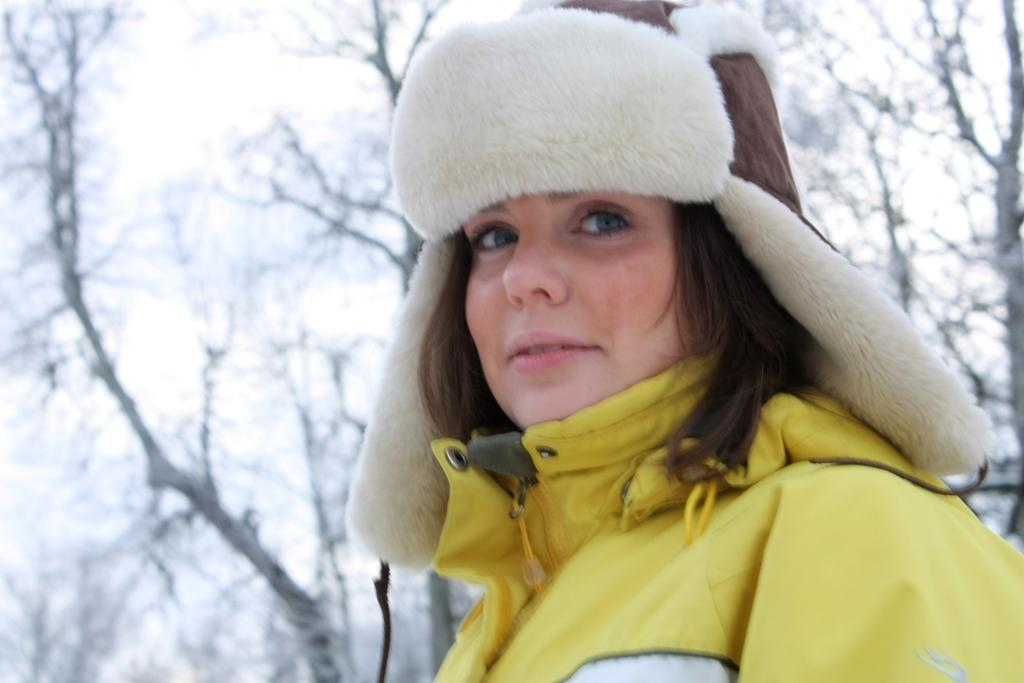Who is the main subject in the image? There is a woman in the image. What is the woman wearing on her upper body? The woman is wearing a yellow jacket. What type of headwear is the woman wearing? The woman is wearing a white-brown cap. What can be seen in the background of the image? Dry trees are visible in the background of the image. What type of grain is being harvested in the image? There is no grain or harvesting activity present in the image. What type of humor can be seen in the woman's facial expression? The image does not show the woman's facial expression, so it is not possible to determine the type of humor. 